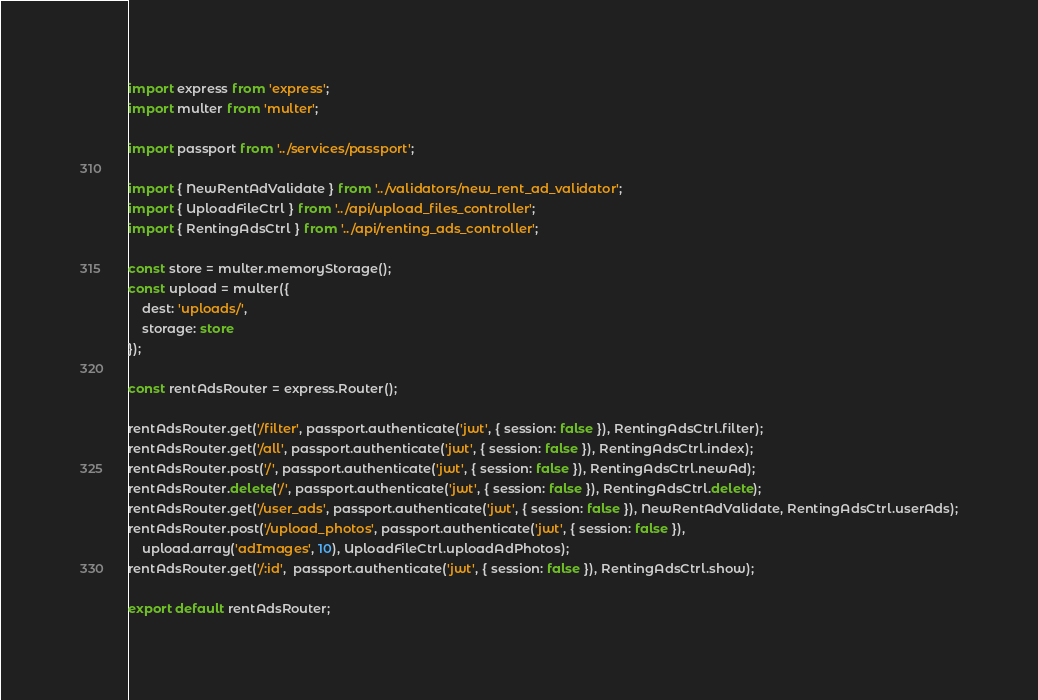Convert code to text. <code><loc_0><loc_0><loc_500><loc_500><_TypeScript_>import express from 'express';
import multer from 'multer';

import passport from '../services/passport';

import { NewRentAdValidate } from '../validators/new_rent_ad_validator';
import { UploadFileCtrl } from '../api/upload_files_controller';
import { RentingAdsCtrl } from '../api/renting_ads_controller';

const store = multer.memoryStorage();
const upload = multer({
    dest: 'uploads/',
    storage: store
});

const rentAdsRouter = express.Router();

rentAdsRouter.get('/filter', passport.authenticate('jwt', { session: false }), RentingAdsCtrl.filter);
rentAdsRouter.get('/all', passport.authenticate('jwt', { session: false }), RentingAdsCtrl.index);
rentAdsRouter.post('/', passport.authenticate('jwt', { session: false }), RentingAdsCtrl.newAd);
rentAdsRouter.delete('/', passport.authenticate('jwt', { session: false }), RentingAdsCtrl.delete);
rentAdsRouter.get('/user_ads', passport.authenticate('jwt', { session: false }), NewRentAdValidate, RentingAdsCtrl.userAds);
rentAdsRouter.post('/upload_photos', passport.authenticate('jwt', { session: false }),
    upload.array('adImages', 10), UploadFileCtrl.uploadAdPhotos);
rentAdsRouter.get('/:id',  passport.authenticate('jwt', { session: false }), RentingAdsCtrl.show);

export default rentAdsRouter;
</code> 